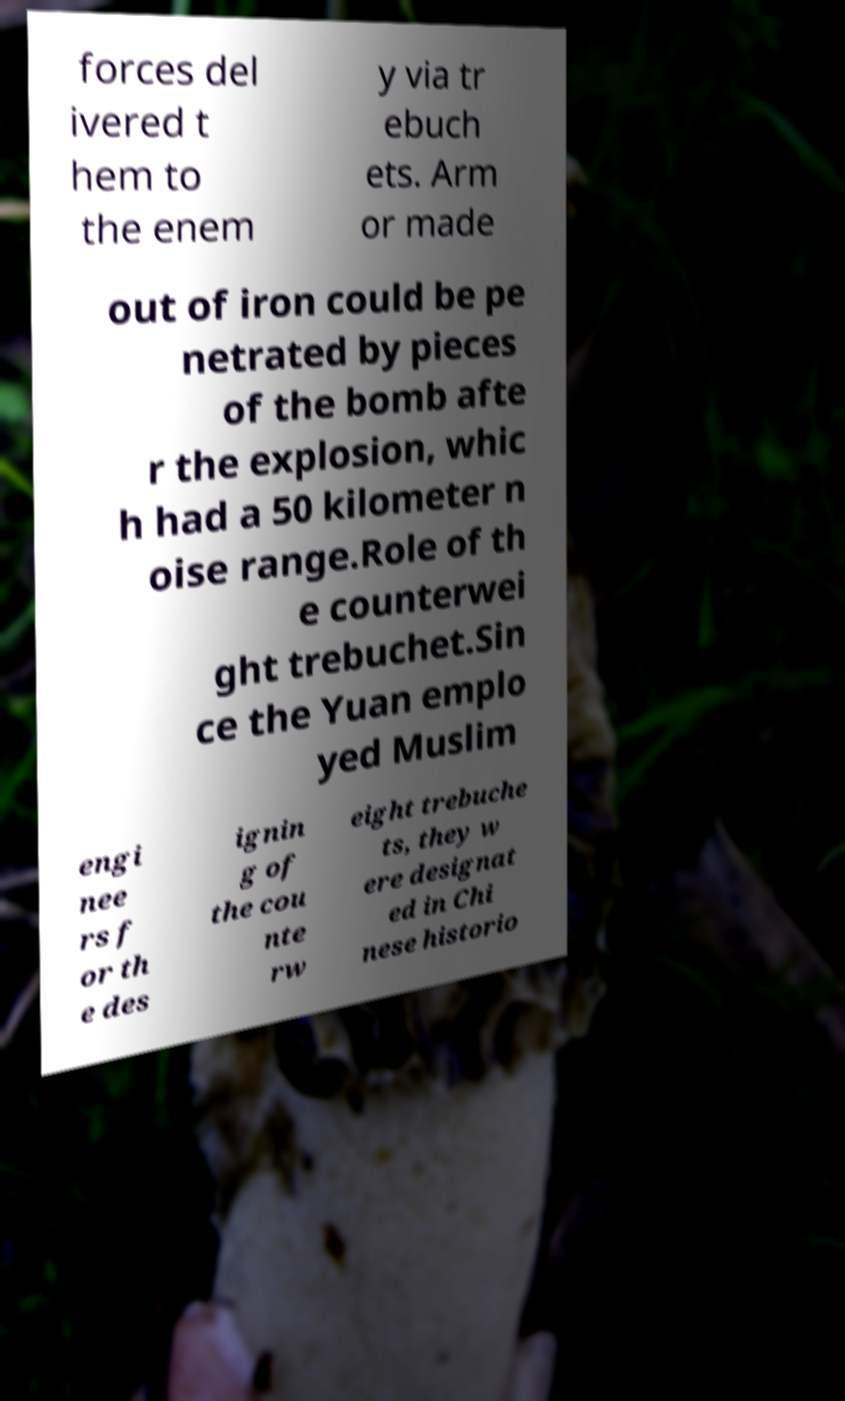For documentation purposes, I need the text within this image transcribed. Could you provide that? forces del ivered t hem to the enem y via tr ebuch ets. Arm or made out of iron could be pe netrated by pieces of the bomb afte r the explosion, whic h had a 50 kilometer n oise range.Role of th e counterwei ght trebuchet.Sin ce the Yuan emplo yed Muslim engi nee rs f or th e des ignin g of the cou nte rw eight trebuche ts, they w ere designat ed in Chi nese historio 